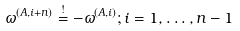<formula> <loc_0><loc_0><loc_500><loc_500>\omega ^ { ( A , i + n ) } \overset { ! } { = } - \omega ^ { ( A , i ) } ; i = 1 , \dots , n - 1</formula> 